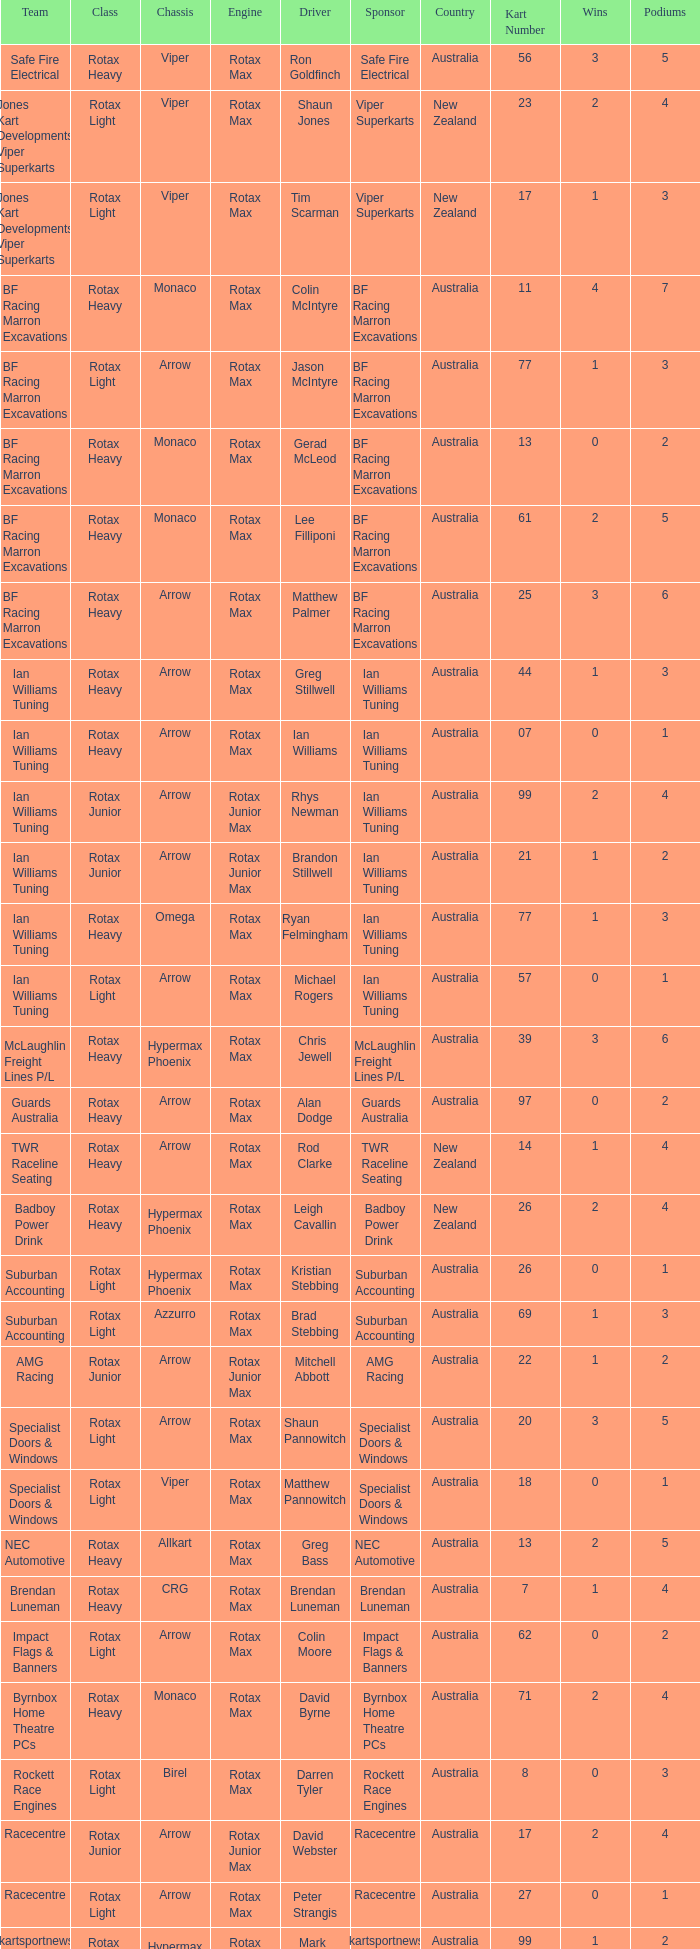What is the name of the driver with a rotax max engine, in the rotax heavy class, with arrow as chassis and on the TWR Raceline Seating team? Rod Clarke. Would you mind parsing the complete table? {'header': ['Team', 'Class', 'Chassis', 'Engine', 'Driver', 'Sponsor', 'Country', 'Kart Number', 'Wins', 'Podiums'], 'rows': [['Safe Fire Electrical', 'Rotax Heavy', 'Viper', 'Rotax Max', 'Ron Goldfinch', 'Safe Fire Electrical', 'Australia', '56', '3', '5'], ['Jones Kart Developments Viper Superkarts', 'Rotax Light', 'Viper', 'Rotax Max', 'Shaun Jones', 'Viper Superkarts', 'New Zealand', '23', '2', '4'], ['Jones Kart Developments Viper Superkarts', 'Rotax Light', 'Viper', 'Rotax Max', 'Tim Scarman', 'Viper Superkarts', 'New Zealand', '17', '1', '3'], ['BF Racing Marron Excavations', 'Rotax Heavy', 'Monaco', 'Rotax Max', 'Colin McIntyre', 'BF Racing Marron Excavations', 'Australia', '11', '4', '7'], ['BF Racing Marron Excavations', 'Rotax Light', 'Arrow', 'Rotax Max', 'Jason McIntyre', 'BF Racing Marron Excavations', 'Australia', '77', '1', '3'], ['BF Racing Marron Excavations', 'Rotax Heavy', 'Monaco', 'Rotax Max', 'Gerad McLeod', 'BF Racing Marron Excavations', 'Australia', '13', '0', '2'], ['BF Racing Marron Excavations', 'Rotax Heavy', 'Monaco', 'Rotax Max', 'Lee Filliponi', 'BF Racing Marron Excavations', 'Australia', '61', '2', '5'], ['BF Racing Marron Excavations', 'Rotax Heavy', 'Arrow', 'Rotax Max', 'Matthew Palmer', 'BF Racing Marron Excavations', 'Australia', '25', '3', '6'], ['Ian Williams Tuning', 'Rotax Heavy', 'Arrow', 'Rotax Max', 'Greg Stillwell', 'Ian Williams Tuning', 'Australia', '44', '1', '3'], ['Ian Williams Tuning', 'Rotax Heavy', 'Arrow', 'Rotax Max', 'Ian Williams', 'Ian Williams Tuning', 'Australia', '07', '0', '1'], ['Ian Williams Tuning', 'Rotax Junior', 'Arrow', 'Rotax Junior Max', 'Rhys Newman', 'Ian Williams Tuning', 'Australia', '99', '2', '4'], ['Ian Williams Tuning', 'Rotax Junior', 'Arrow', 'Rotax Junior Max', 'Brandon Stillwell', 'Ian Williams Tuning', 'Australia', '21', '1', '2'], ['Ian Williams Tuning', 'Rotax Heavy', 'Omega', 'Rotax Max', 'Ryan Felmingham', 'Ian Williams Tuning', 'Australia', '77', '1', '3'], ['Ian Williams Tuning', 'Rotax Light', 'Arrow', 'Rotax Max', 'Michael Rogers', 'Ian Williams Tuning', 'Australia', '57', '0', '1'], ['McLaughlin Freight Lines P/L', 'Rotax Heavy', 'Hypermax Phoenix', 'Rotax Max', 'Chris Jewell', 'McLaughlin Freight Lines P/L', 'Australia', '39', '3', '6'], ['Guards Australia', 'Rotax Heavy', 'Arrow', 'Rotax Max', 'Alan Dodge', 'Guards Australia', 'Australia', '97', '0', '2'], ['TWR Raceline Seating', 'Rotax Heavy', 'Arrow', 'Rotax Max', 'Rod Clarke', 'TWR Raceline Seating', 'New Zealand', '14', '1', '4'], ['Badboy Power Drink', 'Rotax Heavy', 'Hypermax Phoenix', 'Rotax Max', 'Leigh Cavallin', 'Badboy Power Drink', 'New Zealand', '26', '2', '4'], ['Suburban Accounting', 'Rotax Light', 'Hypermax Phoenix', 'Rotax Max', 'Kristian Stebbing', 'Suburban Accounting', 'Australia', '26', '0', '1'], ['Suburban Accounting', 'Rotax Light', 'Azzurro', 'Rotax Max', 'Brad Stebbing', 'Suburban Accounting', 'Australia', '69', '1', '3'], ['AMG Racing', 'Rotax Junior', 'Arrow', 'Rotax Junior Max', 'Mitchell Abbott', 'AMG Racing', 'Australia', '22', '1', '2'], ['Specialist Doors & Windows', 'Rotax Light', 'Arrow', 'Rotax Max', 'Shaun Pannowitch', 'Specialist Doors & Windows', 'Australia', '20', '3', '5'], ['Specialist Doors & Windows', 'Rotax Light', 'Viper', 'Rotax Max', 'Matthew Pannowitch', 'Specialist Doors & Windows', 'Australia', '18', '0', '1'], ['NEC Automotive', 'Rotax Heavy', 'Allkart', 'Rotax Max', 'Greg Bass', 'NEC Automotive', 'Australia', '13', '2', '5'], ['Brendan Luneman', 'Rotax Heavy', 'CRG', 'Rotax Max', 'Brendan Luneman', 'Brendan Luneman', 'Australia', '7', '1', '4'], ['Impact Flags & Banners', 'Rotax Light', 'Arrow', 'Rotax Max', 'Colin Moore', 'Impact Flags & Banners', 'Australia', '62', '0', '2'], ['Byrnbox Home Theatre PCs', 'Rotax Heavy', 'Monaco', 'Rotax Max', 'David Byrne', 'Byrnbox Home Theatre PCs', 'Australia', '71', '2', '4'], ['Rockett Race Engines', 'Rotax Light', 'Birel', 'Rotax Max', 'Darren Tyler', 'Rockett Race Engines', 'Australia', '8', '0', '3'], ['Racecentre', 'Rotax Junior', 'Arrow', 'Rotax Junior Max', 'David Webster', 'Racecentre', 'Australia', '17', '2', '4'], ['Racecentre', 'Rotax Light', 'Arrow', 'Rotax Max', 'Peter Strangis', 'Racecentre', 'Australia', '27', '0', '1'], ['www.kartsportnews.com', 'Rotax Heavy', 'Hypermax Phoenix', 'Rotax Max', 'Mark Wicks', 'www.kartsportnews.com', 'Australia', '99', '1', '2'], ['Doug Savage', 'Rotax Light', 'Arrow', 'Rotax Max', 'Doug Savage', 'Doug Savage', 'New Zealand', '41', '0', '1'], ['Race Stickerz Toyota Material Handling', 'Rotax Heavy', 'Techno', 'Rotax Max', 'Scott Appledore', 'Race Stickerz Toyota Material Handling', 'Australia', '27', '3', '6'], ['Wild Digital', 'Rotax Junior', 'Hypermax Phoenix', 'Rotax Junior Max', 'Sean Whitfield', 'Wild Digital', 'New Zealand', '15', '2', '4'], ['John Bartlett', 'Rotax Heavy', 'Hypermax Phoenix', 'Rotax Max', 'John Bartlett', 'John Bartlett', 'Australia', '91', '1', '2']]} 